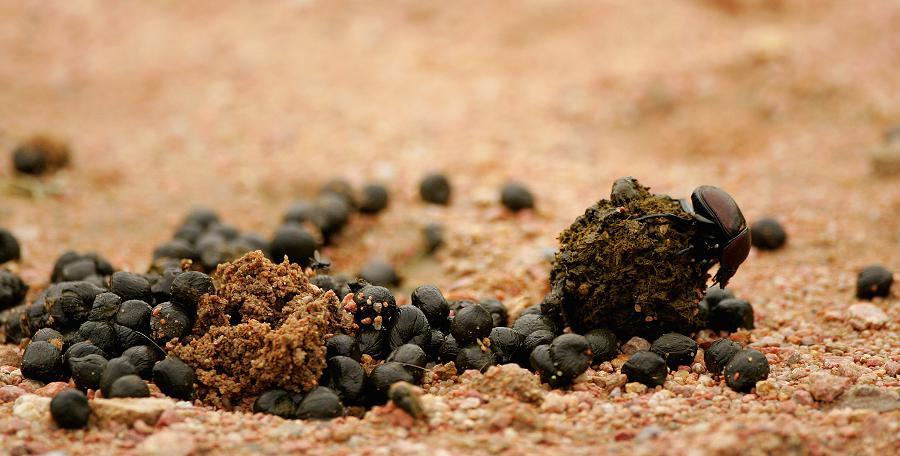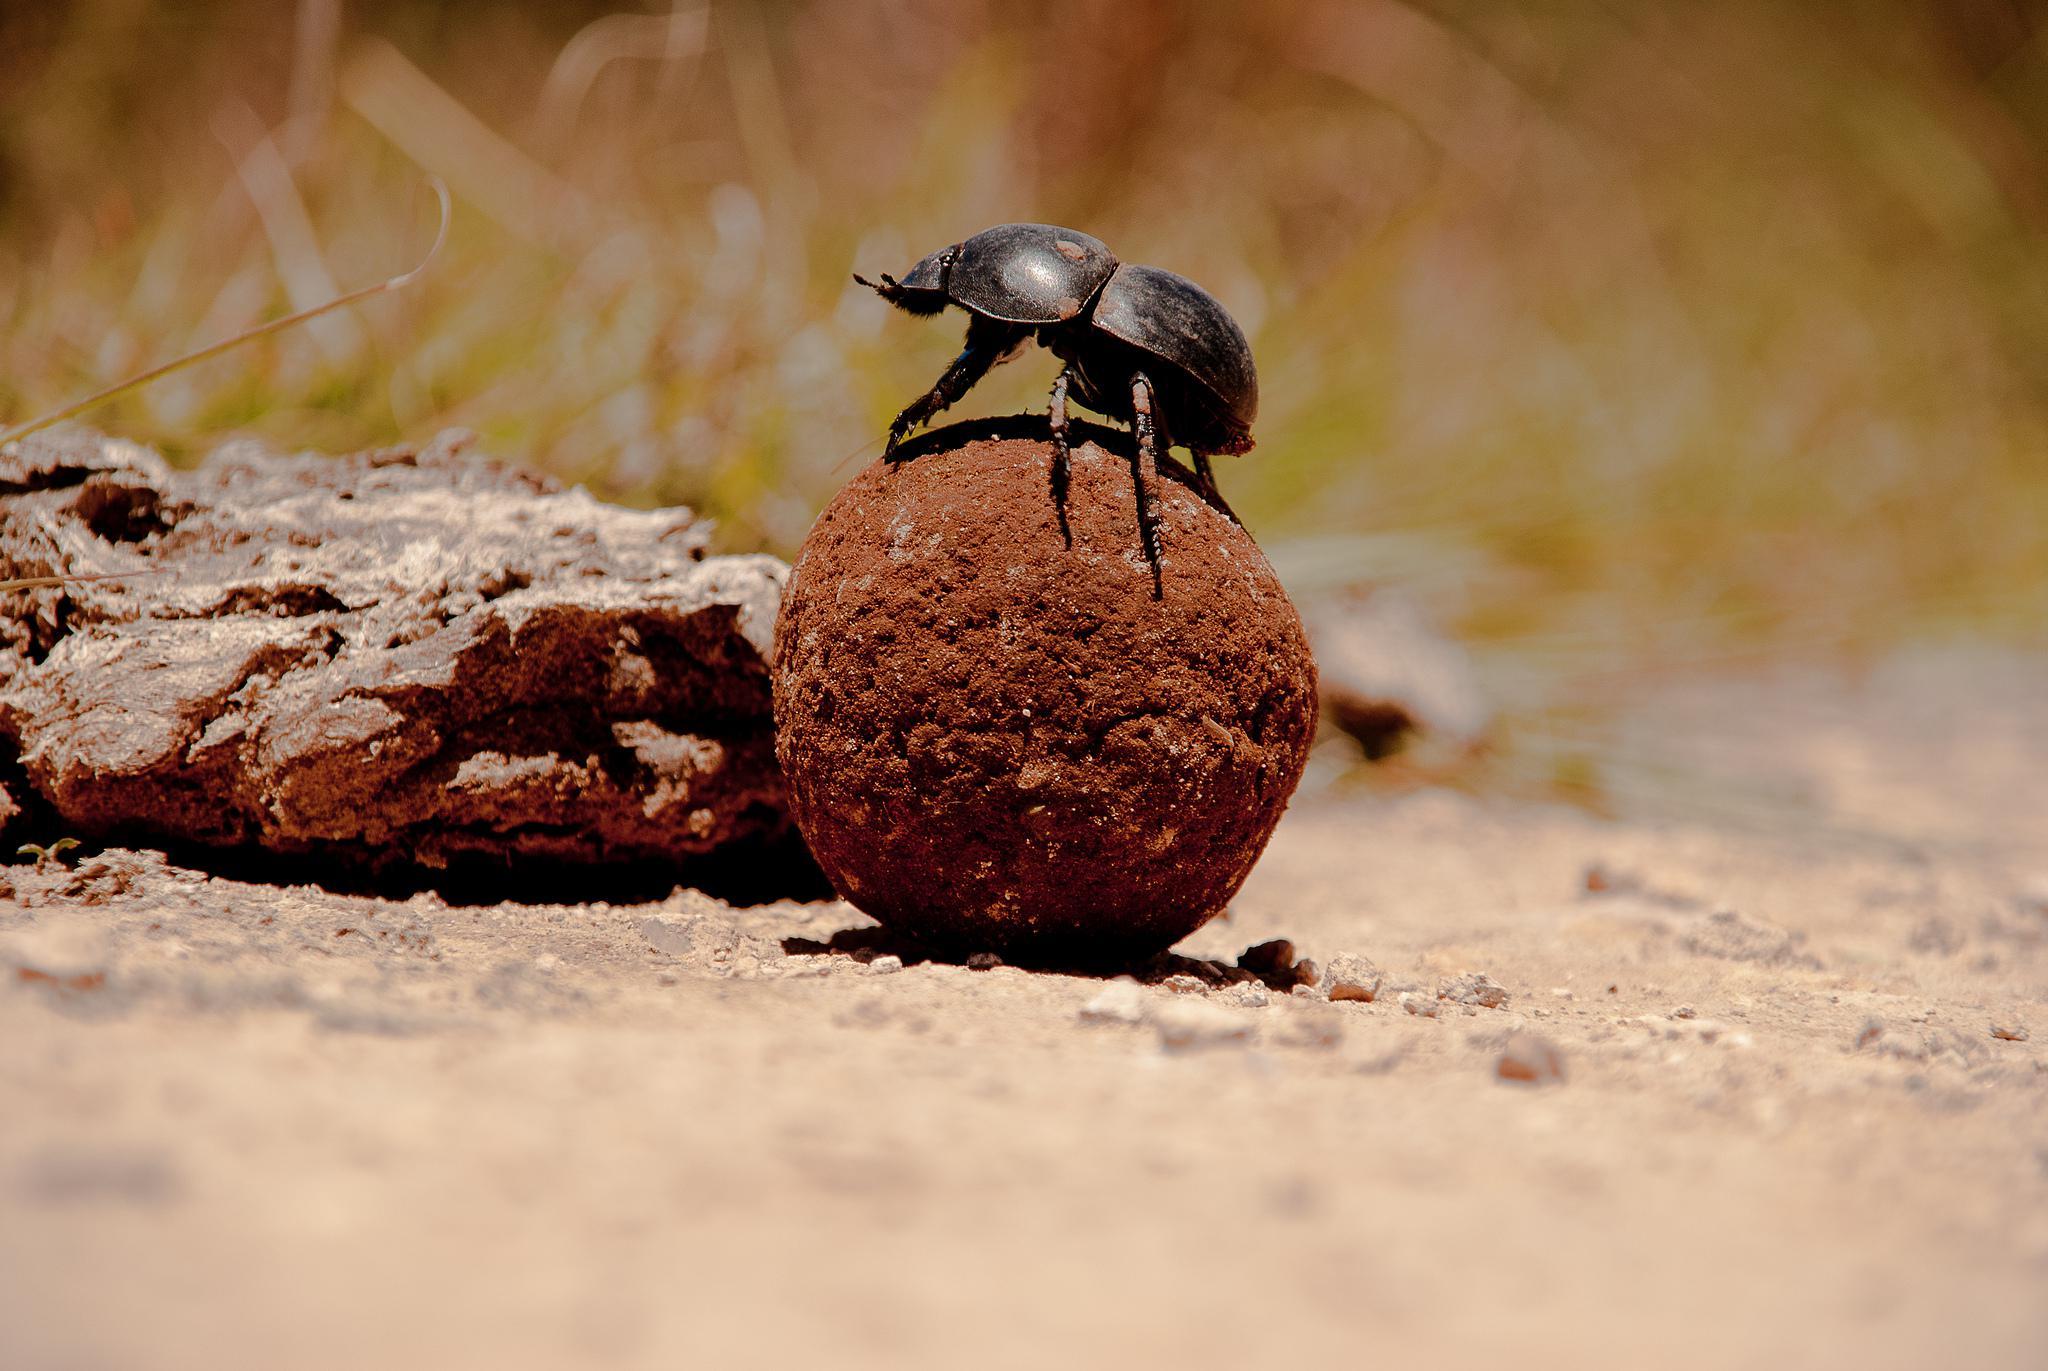The first image is the image on the left, the second image is the image on the right. Given the left and right images, does the statement "An image shows a beetle without a dung ball." hold true? Answer yes or no. No. 